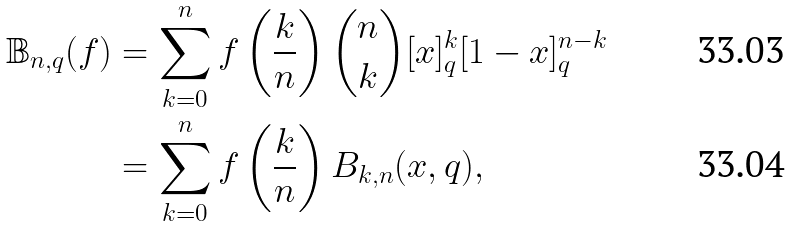Convert formula to latex. <formula><loc_0><loc_0><loc_500><loc_500>\mathbb { B } _ { n , q } ( f ) & = \sum _ { k = 0 } ^ { n } f \left ( \frac { k } { n } \right ) \binom { n } { k } [ x ] _ { q } ^ { k } [ 1 - x ] _ { q } ^ { n - k } \\ & = \sum _ { k = 0 } ^ { n } f \left ( \frac { k } { n } \right ) B _ { k , n } ( x , q ) ,</formula> 